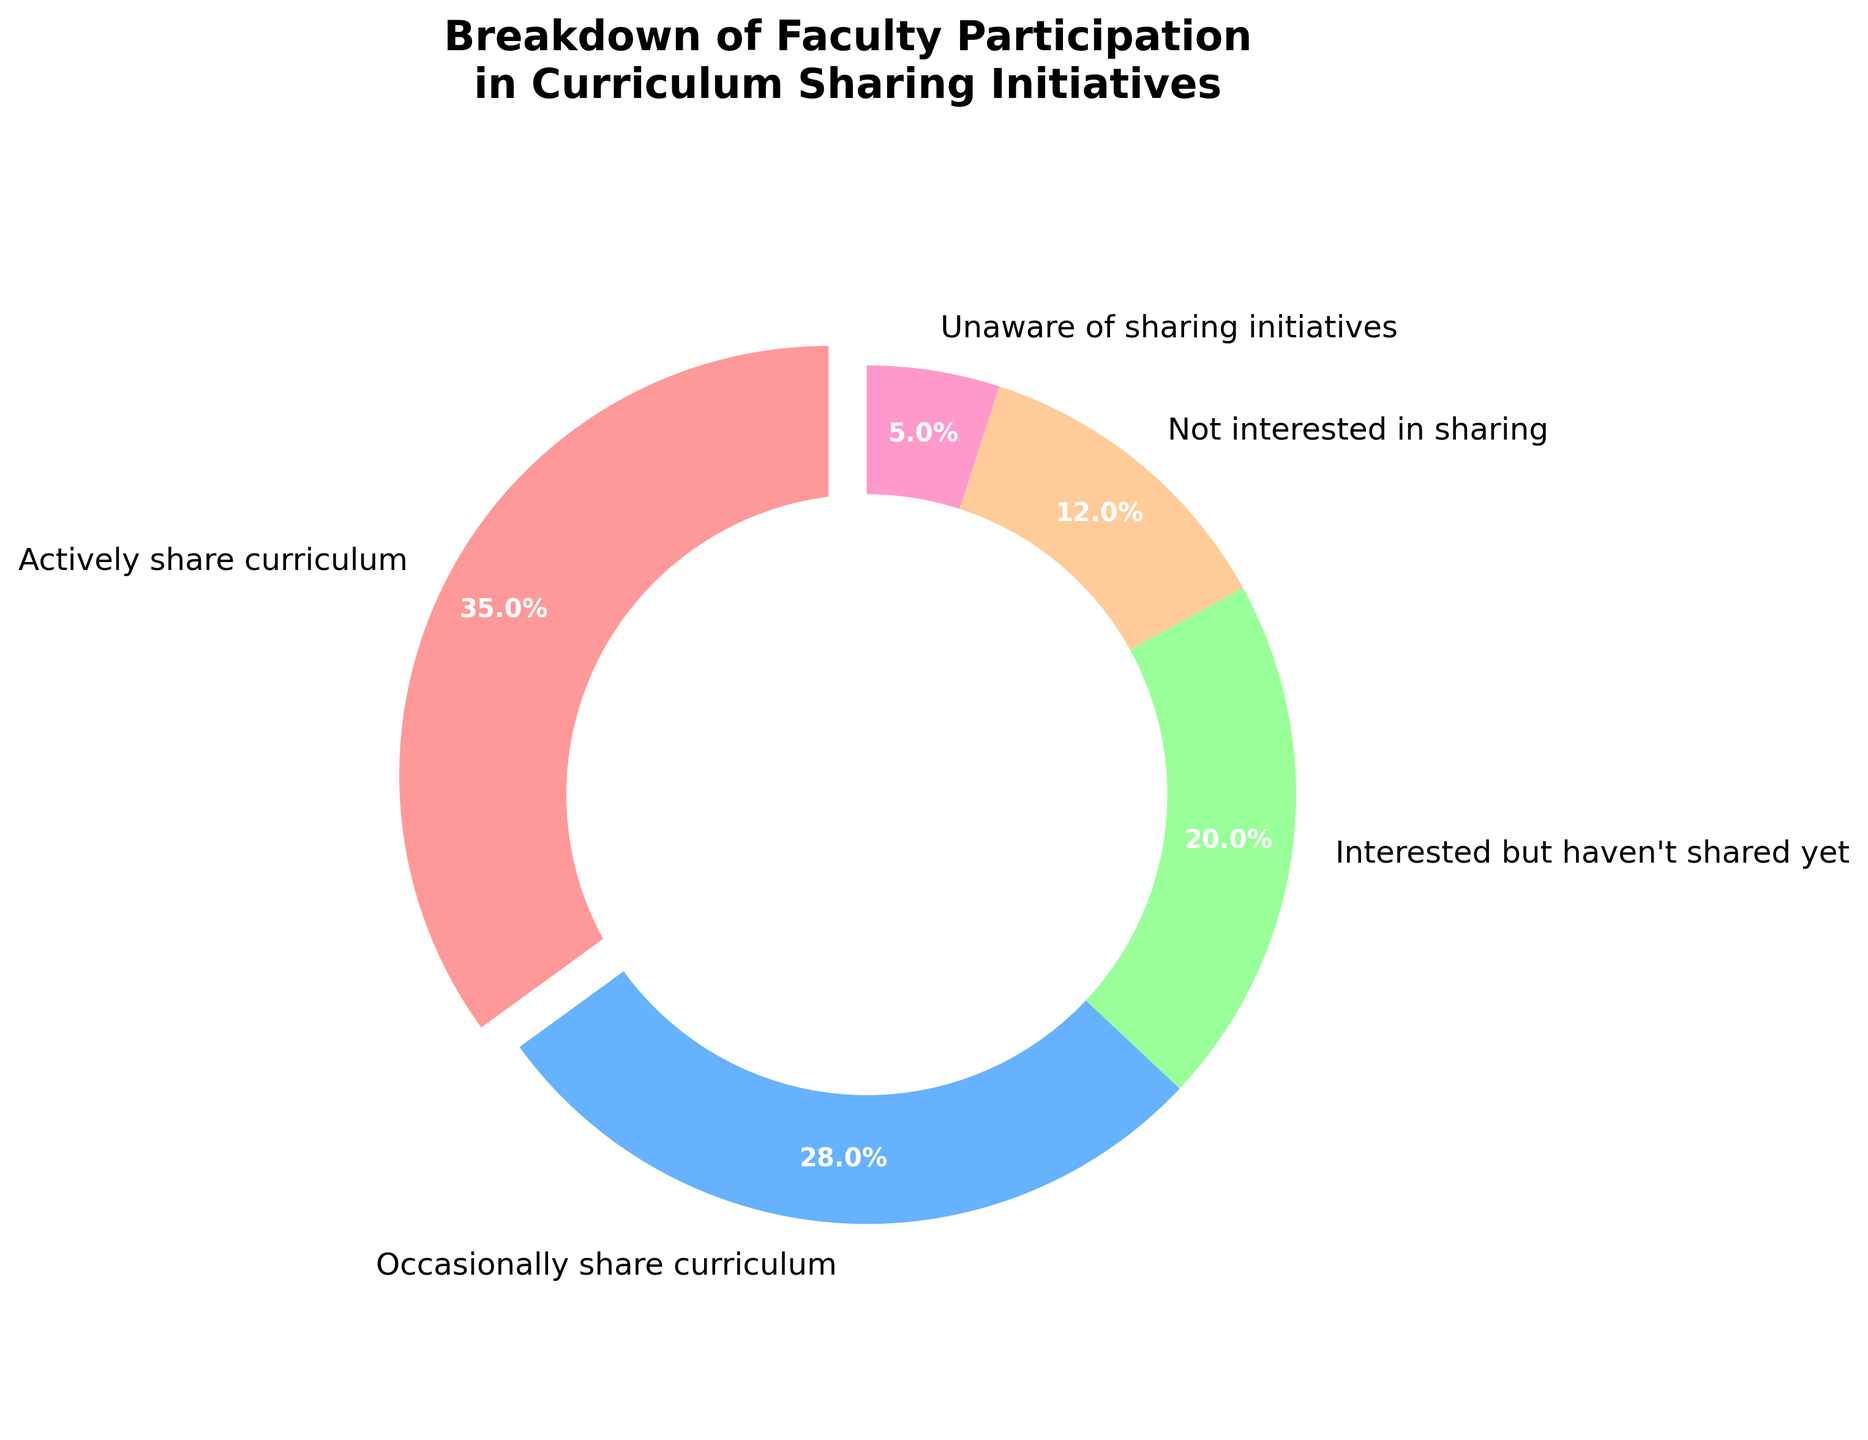What's the percentage of faculty who are actively sharing their curriculum? Look at the section labeled "Actively share curriculum" in the pie chart; it is clearly marked with its percentage.
Answer: 35% What is the combined percentage of faculty who are either actively or occasionally sharing their curriculum? Add the percentages of the sections labeled "Actively share curriculum" and "Occasionally share curriculum": 35% + 28%.
Answer: 63% Is the percentage of faculty not interested in sharing higher or lower than those unaware of sharing initiatives? Compare the percentages directly: "Not interested in sharing" is 12%, and "Unaware of sharing initiatives" is 5%.
Answer: Higher Which category has the smallest representation in the pie chart? Look for the smallest sector in the pie chart; it is the one labeled "Unaware of sharing initiatives."
Answer: Unaware of sharing initiatives What proportion of faculty have not engaged in sharing their curriculum, including those interested but haven't shared yet? Add the percentages of "Interested but haven't shared yet," "Not interested in sharing," and "Unaware of sharing initiatives": 20% + 12% + 5%.
Answer: 37% Which category is indicated by the red color, and what percentage does it represent? Observe the pie chart and identify the sector filled with red color. It's "Actively share curriculum," which represents 35%.
Answer: Actively share curriculum, 35% What is the difference in percentage between faculty occasionally sharing their curriculum and those who are unaware of sharing initiatives? Subtract the percentage of "Unaware of sharing initiatives" from "Occasionally share curriculum": 28% - 5%.
Answer: 23% between those who are interested but haven't shared yet and those who occasionally share? Subtract the percentage of "Interested but haven't shared yet" from "Occasionally share curriculum": 28% - 20%.
Answer: 8% What is the visual feature that highlights the "Actively share curriculum" category in the chart? Identify the distinct visual element in the pie chart for the "Actively share curriculum" sector, which is that it's exploded (pulled out).
Answer: It's exploded Identify two categories whose combined total forms the smallest portion of the chart. Add up the percentages of different combinations and find the smallest sum: "Not interested in sharing" (12%) and "Unaware of sharing initiatives" (5%).
Answer: Not interested in sharing, Unaware of sharing initiatives 